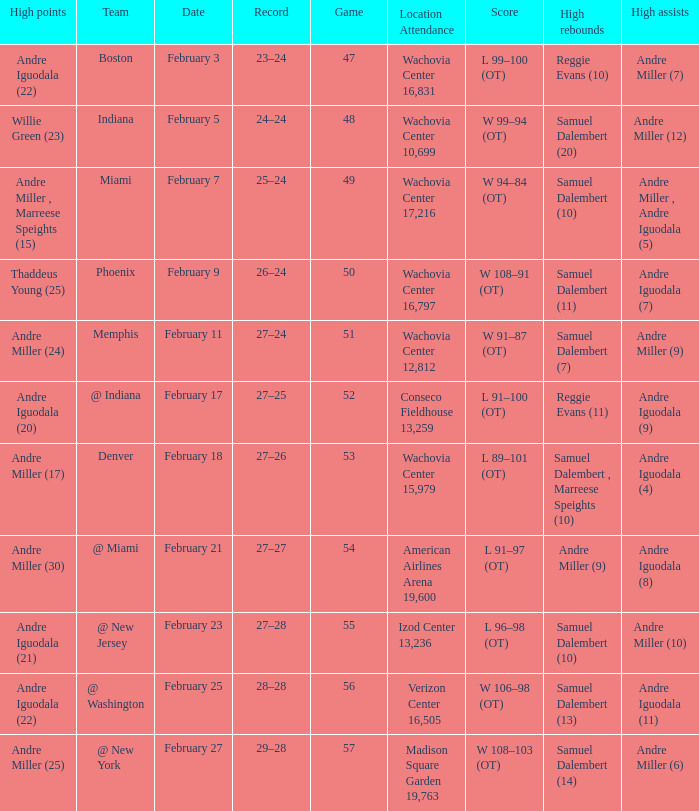Could you parse the entire table as a dict? {'header': ['High points', 'Team', 'Date', 'Record', 'Game', 'Location Attendance', 'Score', 'High rebounds', 'High assists'], 'rows': [['Andre Iguodala (22)', 'Boston', 'February 3', '23–24', '47', 'Wachovia Center 16,831', 'L 99–100 (OT)', 'Reggie Evans (10)', 'Andre Miller (7)'], ['Willie Green (23)', 'Indiana', 'February 5', '24–24', '48', 'Wachovia Center 10,699', 'W 99–94 (OT)', 'Samuel Dalembert (20)', 'Andre Miller (12)'], ['Andre Miller , Marreese Speights (15)', 'Miami', 'February 7', '25–24', '49', 'Wachovia Center 17,216', 'W 94–84 (OT)', 'Samuel Dalembert (10)', 'Andre Miller , Andre Iguodala (5)'], ['Thaddeus Young (25)', 'Phoenix', 'February 9', '26–24', '50', 'Wachovia Center 16,797', 'W 108–91 (OT)', 'Samuel Dalembert (11)', 'Andre Iguodala (7)'], ['Andre Miller (24)', 'Memphis', 'February 11', '27–24', '51', 'Wachovia Center 12,812', 'W 91–87 (OT)', 'Samuel Dalembert (7)', 'Andre Miller (9)'], ['Andre Iguodala (20)', '@ Indiana', 'February 17', '27–25', '52', 'Conseco Fieldhouse 13,259', 'L 91–100 (OT)', 'Reggie Evans (11)', 'Andre Iguodala (9)'], ['Andre Miller (17)', 'Denver', 'February 18', '27–26', '53', 'Wachovia Center 15,979', 'L 89–101 (OT)', 'Samuel Dalembert , Marreese Speights (10)', 'Andre Iguodala (4)'], ['Andre Miller (30)', '@ Miami', 'February 21', '27–27', '54', 'American Airlines Arena 19,600', 'L 91–97 (OT)', 'Andre Miller (9)', 'Andre Iguodala (8)'], ['Andre Iguodala (21)', '@ New Jersey', 'February 23', '27–28', '55', 'Izod Center 13,236', 'L 96–98 (OT)', 'Samuel Dalembert (10)', 'Andre Miller (10)'], ['Andre Iguodala (22)', '@ Washington', 'February 25', '28–28', '56', 'Verizon Center 16,505', 'W 106–98 (OT)', 'Samuel Dalembert (13)', 'Andre Iguodala (11)'], ['Andre Miller (25)', '@ New York', 'February 27', '29–28', '57', 'Madison Square Garden 19,763', 'W 108–103 (OT)', 'Samuel Dalembert (14)', 'Andre Miller (6)']]} When did they play Miami? February 7. 